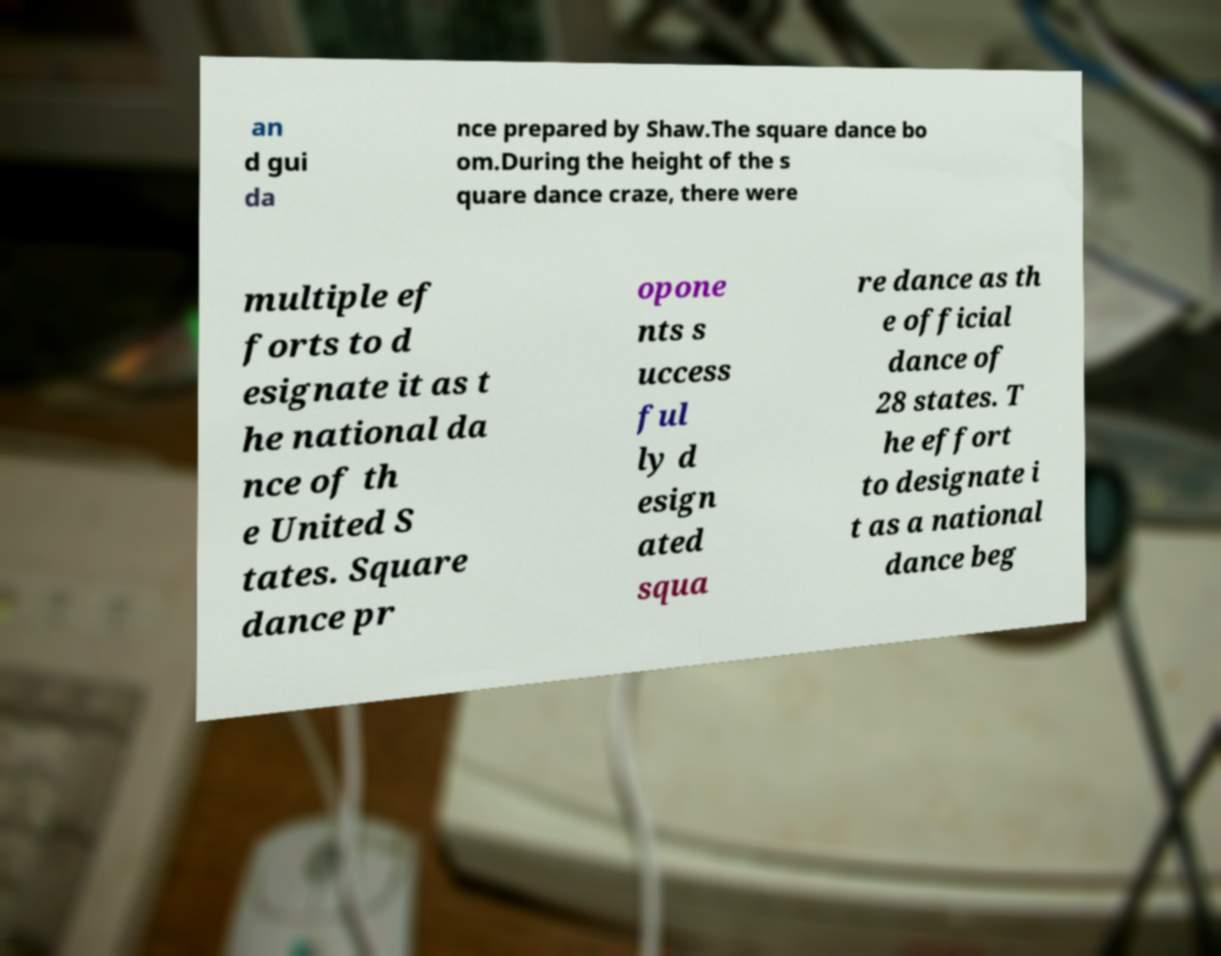What messages or text are displayed in this image? I need them in a readable, typed format. an d gui da nce prepared by Shaw.The square dance bo om.During the height of the s quare dance craze, there were multiple ef forts to d esignate it as t he national da nce of th e United S tates. Square dance pr opone nts s uccess ful ly d esign ated squa re dance as th e official dance of 28 states. T he effort to designate i t as a national dance beg 